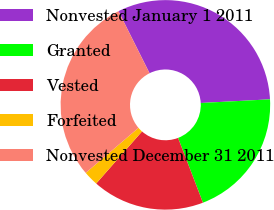Convert chart. <chart><loc_0><loc_0><loc_500><loc_500><pie_chart><fcel>Nonvested January 1 2011<fcel>Granted<fcel>Vested<fcel>Forfeited<fcel>Nonvested December 31 2011<nl><fcel>31.55%<fcel>20.01%<fcel>17.32%<fcel>2.27%<fcel>28.86%<nl></chart> 